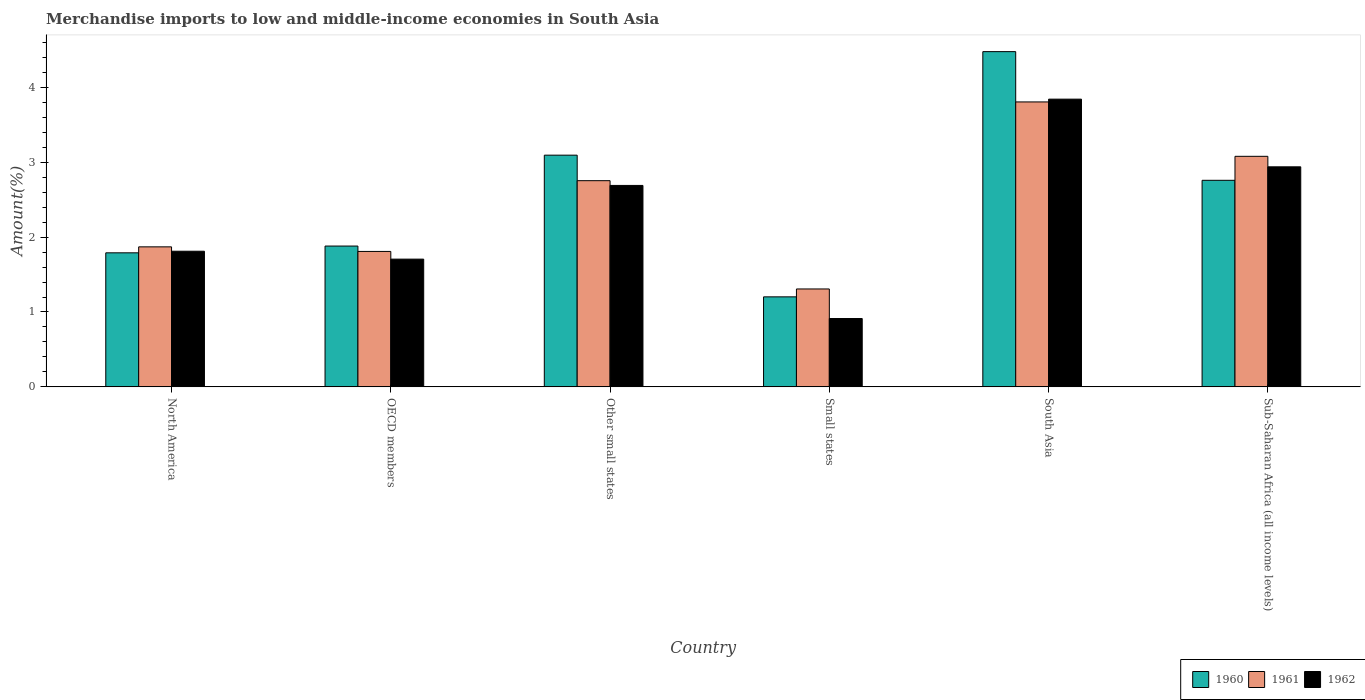How many different coloured bars are there?
Give a very brief answer. 3. How many bars are there on the 5th tick from the left?
Ensure brevity in your answer.  3. How many bars are there on the 6th tick from the right?
Offer a very short reply. 3. What is the label of the 4th group of bars from the left?
Provide a short and direct response. Small states. What is the percentage of amount earned from merchandise imports in 1960 in Other small states?
Your answer should be very brief. 3.09. Across all countries, what is the maximum percentage of amount earned from merchandise imports in 1962?
Offer a terse response. 3.84. Across all countries, what is the minimum percentage of amount earned from merchandise imports in 1960?
Offer a terse response. 1.2. In which country was the percentage of amount earned from merchandise imports in 1960 maximum?
Your answer should be compact. South Asia. In which country was the percentage of amount earned from merchandise imports in 1960 minimum?
Make the answer very short. Small states. What is the total percentage of amount earned from merchandise imports in 1962 in the graph?
Your answer should be compact. 13.9. What is the difference between the percentage of amount earned from merchandise imports in 1960 in Other small states and that in Small states?
Your answer should be very brief. 1.89. What is the difference between the percentage of amount earned from merchandise imports in 1962 in North America and the percentage of amount earned from merchandise imports in 1960 in Small states?
Make the answer very short. 0.61. What is the average percentage of amount earned from merchandise imports in 1961 per country?
Offer a terse response. 2.44. What is the difference between the percentage of amount earned from merchandise imports of/in 1960 and percentage of amount earned from merchandise imports of/in 1961 in Other small states?
Keep it short and to the point. 0.34. In how many countries, is the percentage of amount earned from merchandise imports in 1962 greater than 1.2 %?
Give a very brief answer. 5. What is the ratio of the percentage of amount earned from merchandise imports in 1960 in North America to that in Small states?
Ensure brevity in your answer.  1.49. Is the difference between the percentage of amount earned from merchandise imports in 1960 in North America and South Asia greater than the difference between the percentage of amount earned from merchandise imports in 1961 in North America and South Asia?
Offer a terse response. No. What is the difference between the highest and the second highest percentage of amount earned from merchandise imports in 1960?
Your answer should be compact. -0.34. What is the difference between the highest and the lowest percentage of amount earned from merchandise imports in 1961?
Your response must be concise. 2.5. What does the 1st bar from the left in Small states represents?
Offer a very short reply. 1960. Is it the case that in every country, the sum of the percentage of amount earned from merchandise imports in 1961 and percentage of amount earned from merchandise imports in 1962 is greater than the percentage of amount earned from merchandise imports in 1960?
Your response must be concise. Yes. How many bars are there?
Keep it short and to the point. 18. How many countries are there in the graph?
Your answer should be compact. 6. What is the difference between two consecutive major ticks on the Y-axis?
Offer a terse response. 1. Are the values on the major ticks of Y-axis written in scientific E-notation?
Offer a terse response. No. Where does the legend appear in the graph?
Ensure brevity in your answer.  Bottom right. How many legend labels are there?
Give a very brief answer. 3. What is the title of the graph?
Offer a very short reply. Merchandise imports to low and middle-income economies in South Asia. What is the label or title of the X-axis?
Offer a terse response. Country. What is the label or title of the Y-axis?
Your answer should be very brief. Amount(%). What is the Amount(%) in 1960 in North America?
Ensure brevity in your answer.  1.79. What is the Amount(%) in 1961 in North America?
Make the answer very short. 1.87. What is the Amount(%) of 1962 in North America?
Your answer should be compact. 1.81. What is the Amount(%) of 1960 in OECD members?
Provide a succinct answer. 1.88. What is the Amount(%) in 1961 in OECD members?
Offer a very short reply. 1.81. What is the Amount(%) in 1962 in OECD members?
Provide a short and direct response. 1.71. What is the Amount(%) of 1960 in Other small states?
Provide a short and direct response. 3.09. What is the Amount(%) of 1961 in Other small states?
Your answer should be very brief. 2.75. What is the Amount(%) of 1962 in Other small states?
Your response must be concise. 2.69. What is the Amount(%) in 1960 in Small states?
Make the answer very short. 1.2. What is the Amount(%) in 1961 in Small states?
Provide a short and direct response. 1.31. What is the Amount(%) of 1962 in Small states?
Your answer should be compact. 0.91. What is the Amount(%) of 1960 in South Asia?
Provide a succinct answer. 4.48. What is the Amount(%) in 1961 in South Asia?
Give a very brief answer. 3.8. What is the Amount(%) in 1962 in South Asia?
Offer a terse response. 3.84. What is the Amount(%) of 1960 in Sub-Saharan Africa (all income levels)?
Provide a short and direct response. 2.76. What is the Amount(%) in 1961 in Sub-Saharan Africa (all income levels)?
Your response must be concise. 3.08. What is the Amount(%) of 1962 in Sub-Saharan Africa (all income levels)?
Ensure brevity in your answer.  2.94. Across all countries, what is the maximum Amount(%) of 1960?
Your answer should be very brief. 4.48. Across all countries, what is the maximum Amount(%) of 1961?
Offer a very short reply. 3.8. Across all countries, what is the maximum Amount(%) in 1962?
Give a very brief answer. 3.84. Across all countries, what is the minimum Amount(%) in 1960?
Provide a short and direct response. 1.2. Across all countries, what is the minimum Amount(%) of 1961?
Make the answer very short. 1.31. Across all countries, what is the minimum Amount(%) in 1962?
Keep it short and to the point. 0.91. What is the total Amount(%) in 1960 in the graph?
Provide a succinct answer. 15.2. What is the total Amount(%) in 1961 in the graph?
Your answer should be compact. 14.62. What is the total Amount(%) of 1962 in the graph?
Keep it short and to the point. 13.9. What is the difference between the Amount(%) in 1960 in North America and that in OECD members?
Keep it short and to the point. -0.09. What is the difference between the Amount(%) in 1961 in North America and that in OECD members?
Offer a very short reply. 0.06. What is the difference between the Amount(%) in 1962 in North America and that in OECD members?
Your response must be concise. 0.11. What is the difference between the Amount(%) of 1960 in North America and that in Other small states?
Keep it short and to the point. -1.3. What is the difference between the Amount(%) of 1961 in North America and that in Other small states?
Your answer should be very brief. -0.88. What is the difference between the Amount(%) in 1962 in North America and that in Other small states?
Keep it short and to the point. -0.88. What is the difference between the Amount(%) in 1960 in North America and that in Small states?
Your answer should be compact. 0.59. What is the difference between the Amount(%) in 1961 in North America and that in Small states?
Keep it short and to the point. 0.56. What is the difference between the Amount(%) in 1962 in North America and that in Small states?
Your response must be concise. 0.9. What is the difference between the Amount(%) of 1960 in North America and that in South Asia?
Offer a terse response. -2.69. What is the difference between the Amount(%) of 1961 in North America and that in South Asia?
Ensure brevity in your answer.  -1.94. What is the difference between the Amount(%) of 1962 in North America and that in South Asia?
Keep it short and to the point. -2.03. What is the difference between the Amount(%) in 1960 in North America and that in Sub-Saharan Africa (all income levels)?
Your response must be concise. -0.97. What is the difference between the Amount(%) in 1961 in North America and that in Sub-Saharan Africa (all income levels)?
Offer a terse response. -1.21. What is the difference between the Amount(%) of 1962 in North America and that in Sub-Saharan Africa (all income levels)?
Offer a terse response. -1.13. What is the difference between the Amount(%) of 1960 in OECD members and that in Other small states?
Ensure brevity in your answer.  -1.21. What is the difference between the Amount(%) of 1961 in OECD members and that in Other small states?
Your response must be concise. -0.94. What is the difference between the Amount(%) of 1962 in OECD members and that in Other small states?
Provide a succinct answer. -0.98. What is the difference between the Amount(%) of 1960 in OECD members and that in Small states?
Provide a succinct answer. 0.68. What is the difference between the Amount(%) of 1961 in OECD members and that in Small states?
Your response must be concise. 0.5. What is the difference between the Amount(%) of 1962 in OECD members and that in Small states?
Provide a short and direct response. 0.79. What is the difference between the Amount(%) in 1960 in OECD members and that in South Asia?
Provide a short and direct response. -2.6. What is the difference between the Amount(%) in 1961 in OECD members and that in South Asia?
Ensure brevity in your answer.  -2. What is the difference between the Amount(%) of 1962 in OECD members and that in South Asia?
Your response must be concise. -2.14. What is the difference between the Amount(%) in 1960 in OECD members and that in Sub-Saharan Africa (all income levels)?
Keep it short and to the point. -0.88. What is the difference between the Amount(%) of 1961 in OECD members and that in Sub-Saharan Africa (all income levels)?
Your answer should be very brief. -1.27. What is the difference between the Amount(%) of 1962 in OECD members and that in Sub-Saharan Africa (all income levels)?
Offer a terse response. -1.23. What is the difference between the Amount(%) in 1960 in Other small states and that in Small states?
Keep it short and to the point. 1.89. What is the difference between the Amount(%) of 1961 in Other small states and that in Small states?
Ensure brevity in your answer.  1.45. What is the difference between the Amount(%) of 1962 in Other small states and that in Small states?
Make the answer very short. 1.78. What is the difference between the Amount(%) in 1960 in Other small states and that in South Asia?
Give a very brief answer. -1.38. What is the difference between the Amount(%) of 1961 in Other small states and that in South Asia?
Offer a very short reply. -1.05. What is the difference between the Amount(%) of 1962 in Other small states and that in South Asia?
Give a very brief answer. -1.15. What is the difference between the Amount(%) of 1960 in Other small states and that in Sub-Saharan Africa (all income levels)?
Provide a short and direct response. 0.34. What is the difference between the Amount(%) of 1961 in Other small states and that in Sub-Saharan Africa (all income levels)?
Your answer should be compact. -0.33. What is the difference between the Amount(%) in 1962 in Other small states and that in Sub-Saharan Africa (all income levels)?
Give a very brief answer. -0.25. What is the difference between the Amount(%) in 1960 in Small states and that in South Asia?
Your answer should be compact. -3.27. What is the difference between the Amount(%) of 1961 in Small states and that in South Asia?
Offer a terse response. -2.5. What is the difference between the Amount(%) of 1962 in Small states and that in South Asia?
Your response must be concise. -2.93. What is the difference between the Amount(%) in 1960 in Small states and that in Sub-Saharan Africa (all income levels)?
Offer a very short reply. -1.56. What is the difference between the Amount(%) of 1961 in Small states and that in Sub-Saharan Africa (all income levels)?
Offer a terse response. -1.77. What is the difference between the Amount(%) in 1962 in Small states and that in Sub-Saharan Africa (all income levels)?
Your answer should be very brief. -2.03. What is the difference between the Amount(%) in 1960 in South Asia and that in Sub-Saharan Africa (all income levels)?
Your answer should be very brief. 1.72. What is the difference between the Amount(%) of 1961 in South Asia and that in Sub-Saharan Africa (all income levels)?
Your response must be concise. 0.73. What is the difference between the Amount(%) of 1962 in South Asia and that in Sub-Saharan Africa (all income levels)?
Provide a succinct answer. 0.9. What is the difference between the Amount(%) in 1960 in North America and the Amount(%) in 1961 in OECD members?
Offer a terse response. -0.02. What is the difference between the Amount(%) of 1960 in North America and the Amount(%) of 1962 in OECD members?
Your response must be concise. 0.08. What is the difference between the Amount(%) of 1961 in North America and the Amount(%) of 1962 in OECD members?
Provide a short and direct response. 0.16. What is the difference between the Amount(%) of 1960 in North America and the Amount(%) of 1961 in Other small states?
Offer a very short reply. -0.96. What is the difference between the Amount(%) of 1960 in North America and the Amount(%) of 1962 in Other small states?
Ensure brevity in your answer.  -0.9. What is the difference between the Amount(%) of 1961 in North America and the Amount(%) of 1962 in Other small states?
Offer a very short reply. -0.82. What is the difference between the Amount(%) in 1960 in North America and the Amount(%) in 1961 in Small states?
Your response must be concise. 0.48. What is the difference between the Amount(%) of 1960 in North America and the Amount(%) of 1962 in Small states?
Ensure brevity in your answer.  0.88. What is the difference between the Amount(%) in 1961 in North America and the Amount(%) in 1962 in Small states?
Your answer should be compact. 0.96. What is the difference between the Amount(%) in 1960 in North America and the Amount(%) in 1961 in South Asia?
Make the answer very short. -2.01. What is the difference between the Amount(%) in 1960 in North America and the Amount(%) in 1962 in South Asia?
Provide a short and direct response. -2.05. What is the difference between the Amount(%) of 1961 in North America and the Amount(%) of 1962 in South Asia?
Offer a very short reply. -1.97. What is the difference between the Amount(%) in 1960 in North America and the Amount(%) in 1961 in Sub-Saharan Africa (all income levels)?
Provide a short and direct response. -1.29. What is the difference between the Amount(%) in 1960 in North America and the Amount(%) in 1962 in Sub-Saharan Africa (all income levels)?
Offer a very short reply. -1.15. What is the difference between the Amount(%) in 1961 in North America and the Amount(%) in 1962 in Sub-Saharan Africa (all income levels)?
Keep it short and to the point. -1.07. What is the difference between the Amount(%) in 1960 in OECD members and the Amount(%) in 1961 in Other small states?
Your answer should be compact. -0.87. What is the difference between the Amount(%) of 1960 in OECD members and the Amount(%) of 1962 in Other small states?
Keep it short and to the point. -0.81. What is the difference between the Amount(%) of 1961 in OECD members and the Amount(%) of 1962 in Other small states?
Your response must be concise. -0.88. What is the difference between the Amount(%) in 1960 in OECD members and the Amount(%) in 1961 in Small states?
Provide a short and direct response. 0.57. What is the difference between the Amount(%) of 1960 in OECD members and the Amount(%) of 1962 in Small states?
Your answer should be compact. 0.97. What is the difference between the Amount(%) of 1961 in OECD members and the Amount(%) of 1962 in Small states?
Ensure brevity in your answer.  0.9. What is the difference between the Amount(%) of 1960 in OECD members and the Amount(%) of 1961 in South Asia?
Ensure brevity in your answer.  -1.92. What is the difference between the Amount(%) of 1960 in OECD members and the Amount(%) of 1962 in South Asia?
Provide a succinct answer. -1.96. What is the difference between the Amount(%) of 1961 in OECD members and the Amount(%) of 1962 in South Asia?
Your answer should be very brief. -2.03. What is the difference between the Amount(%) of 1960 in OECD members and the Amount(%) of 1961 in Sub-Saharan Africa (all income levels)?
Make the answer very short. -1.2. What is the difference between the Amount(%) of 1960 in OECD members and the Amount(%) of 1962 in Sub-Saharan Africa (all income levels)?
Your answer should be very brief. -1.06. What is the difference between the Amount(%) of 1961 in OECD members and the Amount(%) of 1962 in Sub-Saharan Africa (all income levels)?
Ensure brevity in your answer.  -1.13. What is the difference between the Amount(%) in 1960 in Other small states and the Amount(%) in 1961 in Small states?
Offer a terse response. 1.79. What is the difference between the Amount(%) of 1960 in Other small states and the Amount(%) of 1962 in Small states?
Provide a short and direct response. 2.18. What is the difference between the Amount(%) of 1961 in Other small states and the Amount(%) of 1962 in Small states?
Your answer should be very brief. 1.84. What is the difference between the Amount(%) of 1960 in Other small states and the Amount(%) of 1961 in South Asia?
Keep it short and to the point. -0.71. What is the difference between the Amount(%) of 1960 in Other small states and the Amount(%) of 1962 in South Asia?
Offer a terse response. -0.75. What is the difference between the Amount(%) in 1961 in Other small states and the Amount(%) in 1962 in South Asia?
Ensure brevity in your answer.  -1.09. What is the difference between the Amount(%) of 1960 in Other small states and the Amount(%) of 1961 in Sub-Saharan Africa (all income levels)?
Your answer should be compact. 0.02. What is the difference between the Amount(%) in 1960 in Other small states and the Amount(%) in 1962 in Sub-Saharan Africa (all income levels)?
Keep it short and to the point. 0.16. What is the difference between the Amount(%) in 1961 in Other small states and the Amount(%) in 1962 in Sub-Saharan Africa (all income levels)?
Your answer should be very brief. -0.18. What is the difference between the Amount(%) in 1960 in Small states and the Amount(%) in 1961 in South Asia?
Ensure brevity in your answer.  -2.6. What is the difference between the Amount(%) of 1960 in Small states and the Amount(%) of 1962 in South Asia?
Give a very brief answer. -2.64. What is the difference between the Amount(%) of 1961 in Small states and the Amount(%) of 1962 in South Asia?
Provide a short and direct response. -2.53. What is the difference between the Amount(%) of 1960 in Small states and the Amount(%) of 1961 in Sub-Saharan Africa (all income levels)?
Offer a very short reply. -1.88. What is the difference between the Amount(%) of 1960 in Small states and the Amount(%) of 1962 in Sub-Saharan Africa (all income levels)?
Your answer should be compact. -1.74. What is the difference between the Amount(%) in 1961 in Small states and the Amount(%) in 1962 in Sub-Saharan Africa (all income levels)?
Ensure brevity in your answer.  -1.63. What is the difference between the Amount(%) in 1960 in South Asia and the Amount(%) in 1961 in Sub-Saharan Africa (all income levels)?
Your answer should be compact. 1.4. What is the difference between the Amount(%) of 1960 in South Asia and the Amount(%) of 1962 in Sub-Saharan Africa (all income levels)?
Ensure brevity in your answer.  1.54. What is the difference between the Amount(%) in 1961 in South Asia and the Amount(%) in 1962 in Sub-Saharan Africa (all income levels)?
Provide a succinct answer. 0.87. What is the average Amount(%) of 1960 per country?
Your answer should be compact. 2.53. What is the average Amount(%) in 1961 per country?
Provide a succinct answer. 2.44. What is the average Amount(%) of 1962 per country?
Your answer should be compact. 2.32. What is the difference between the Amount(%) of 1960 and Amount(%) of 1961 in North America?
Provide a short and direct response. -0.08. What is the difference between the Amount(%) of 1960 and Amount(%) of 1962 in North America?
Provide a short and direct response. -0.02. What is the difference between the Amount(%) of 1961 and Amount(%) of 1962 in North America?
Give a very brief answer. 0.06. What is the difference between the Amount(%) of 1960 and Amount(%) of 1961 in OECD members?
Your response must be concise. 0.07. What is the difference between the Amount(%) of 1960 and Amount(%) of 1962 in OECD members?
Give a very brief answer. 0.17. What is the difference between the Amount(%) of 1961 and Amount(%) of 1962 in OECD members?
Ensure brevity in your answer.  0.1. What is the difference between the Amount(%) in 1960 and Amount(%) in 1961 in Other small states?
Your answer should be very brief. 0.34. What is the difference between the Amount(%) in 1960 and Amount(%) in 1962 in Other small states?
Your answer should be very brief. 0.4. What is the difference between the Amount(%) in 1961 and Amount(%) in 1962 in Other small states?
Ensure brevity in your answer.  0.06. What is the difference between the Amount(%) in 1960 and Amount(%) in 1961 in Small states?
Offer a terse response. -0.11. What is the difference between the Amount(%) of 1960 and Amount(%) of 1962 in Small states?
Your answer should be compact. 0.29. What is the difference between the Amount(%) in 1961 and Amount(%) in 1962 in Small states?
Provide a short and direct response. 0.39. What is the difference between the Amount(%) of 1960 and Amount(%) of 1961 in South Asia?
Make the answer very short. 0.67. What is the difference between the Amount(%) in 1960 and Amount(%) in 1962 in South Asia?
Make the answer very short. 0.63. What is the difference between the Amount(%) in 1961 and Amount(%) in 1962 in South Asia?
Keep it short and to the point. -0.04. What is the difference between the Amount(%) in 1960 and Amount(%) in 1961 in Sub-Saharan Africa (all income levels)?
Your answer should be compact. -0.32. What is the difference between the Amount(%) in 1960 and Amount(%) in 1962 in Sub-Saharan Africa (all income levels)?
Keep it short and to the point. -0.18. What is the difference between the Amount(%) in 1961 and Amount(%) in 1962 in Sub-Saharan Africa (all income levels)?
Offer a terse response. 0.14. What is the ratio of the Amount(%) of 1960 in North America to that in OECD members?
Your answer should be compact. 0.95. What is the ratio of the Amount(%) of 1961 in North America to that in OECD members?
Your answer should be very brief. 1.03. What is the ratio of the Amount(%) in 1962 in North America to that in OECD members?
Your answer should be very brief. 1.06. What is the ratio of the Amount(%) of 1960 in North America to that in Other small states?
Ensure brevity in your answer.  0.58. What is the ratio of the Amount(%) of 1961 in North America to that in Other small states?
Your response must be concise. 0.68. What is the ratio of the Amount(%) of 1962 in North America to that in Other small states?
Offer a terse response. 0.67. What is the ratio of the Amount(%) of 1960 in North America to that in Small states?
Make the answer very short. 1.49. What is the ratio of the Amount(%) of 1961 in North America to that in Small states?
Your response must be concise. 1.43. What is the ratio of the Amount(%) of 1962 in North America to that in Small states?
Give a very brief answer. 1.98. What is the ratio of the Amount(%) in 1960 in North America to that in South Asia?
Offer a terse response. 0.4. What is the ratio of the Amount(%) of 1961 in North America to that in South Asia?
Offer a very short reply. 0.49. What is the ratio of the Amount(%) in 1962 in North America to that in South Asia?
Keep it short and to the point. 0.47. What is the ratio of the Amount(%) of 1960 in North America to that in Sub-Saharan Africa (all income levels)?
Offer a very short reply. 0.65. What is the ratio of the Amount(%) in 1961 in North America to that in Sub-Saharan Africa (all income levels)?
Your answer should be very brief. 0.61. What is the ratio of the Amount(%) of 1962 in North America to that in Sub-Saharan Africa (all income levels)?
Keep it short and to the point. 0.62. What is the ratio of the Amount(%) of 1960 in OECD members to that in Other small states?
Your answer should be very brief. 0.61. What is the ratio of the Amount(%) of 1961 in OECD members to that in Other small states?
Provide a short and direct response. 0.66. What is the ratio of the Amount(%) in 1962 in OECD members to that in Other small states?
Offer a terse response. 0.63. What is the ratio of the Amount(%) in 1960 in OECD members to that in Small states?
Provide a succinct answer. 1.56. What is the ratio of the Amount(%) in 1961 in OECD members to that in Small states?
Your answer should be very brief. 1.38. What is the ratio of the Amount(%) in 1962 in OECD members to that in Small states?
Your answer should be very brief. 1.87. What is the ratio of the Amount(%) of 1960 in OECD members to that in South Asia?
Offer a very short reply. 0.42. What is the ratio of the Amount(%) of 1961 in OECD members to that in South Asia?
Ensure brevity in your answer.  0.48. What is the ratio of the Amount(%) in 1962 in OECD members to that in South Asia?
Make the answer very short. 0.44. What is the ratio of the Amount(%) of 1960 in OECD members to that in Sub-Saharan Africa (all income levels)?
Give a very brief answer. 0.68. What is the ratio of the Amount(%) of 1961 in OECD members to that in Sub-Saharan Africa (all income levels)?
Provide a short and direct response. 0.59. What is the ratio of the Amount(%) of 1962 in OECD members to that in Sub-Saharan Africa (all income levels)?
Provide a short and direct response. 0.58. What is the ratio of the Amount(%) in 1960 in Other small states to that in Small states?
Offer a very short reply. 2.57. What is the ratio of the Amount(%) of 1961 in Other small states to that in Small states?
Make the answer very short. 2.11. What is the ratio of the Amount(%) of 1962 in Other small states to that in Small states?
Offer a terse response. 2.95. What is the ratio of the Amount(%) in 1960 in Other small states to that in South Asia?
Offer a terse response. 0.69. What is the ratio of the Amount(%) in 1961 in Other small states to that in South Asia?
Provide a succinct answer. 0.72. What is the ratio of the Amount(%) of 1962 in Other small states to that in South Asia?
Your answer should be compact. 0.7. What is the ratio of the Amount(%) in 1960 in Other small states to that in Sub-Saharan Africa (all income levels)?
Provide a short and direct response. 1.12. What is the ratio of the Amount(%) of 1961 in Other small states to that in Sub-Saharan Africa (all income levels)?
Your response must be concise. 0.89. What is the ratio of the Amount(%) of 1962 in Other small states to that in Sub-Saharan Africa (all income levels)?
Give a very brief answer. 0.92. What is the ratio of the Amount(%) of 1960 in Small states to that in South Asia?
Ensure brevity in your answer.  0.27. What is the ratio of the Amount(%) in 1961 in Small states to that in South Asia?
Ensure brevity in your answer.  0.34. What is the ratio of the Amount(%) in 1962 in Small states to that in South Asia?
Your answer should be very brief. 0.24. What is the ratio of the Amount(%) in 1960 in Small states to that in Sub-Saharan Africa (all income levels)?
Your answer should be compact. 0.44. What is the ratio of the Amount(%) of 1961 in Small states to that in Sub-Saharan Africa (all income levels)?
Your answer should be compact. 0.42. What is the ratio of the Amount(%) in 1962 in Small states to that in Sub-Saharan Africa (all income levels)?
Make the answer very short. 0.31. What is the ratio of the Amount(%) of 1960 in South Asia to that in Sub-Saharan Africa (all income levels)?
Ensure brevity in your answer.  1.62. What is the ratio of the Amount(%) in 1961 in South Asia to that in Sub-Saharan Africa (all income levels)?
Provide a short and direct response. 1.24. What is the ratio of the Amount(%) in 1962 in South Asia to that in Sub-Saharan Africa (all income levels)?
Give a very brief answer. 1.31. What is the difference between the highest and the second highest Amount(%) in 1960?
Provide a short and direct response. 1.38. What is the difference between the highest and the second highest Amount(%) of 1961?
Provide a succinct answer. 0.73. What is the difference between the highest and the second highest Amount(%) of 1962?
Provide a succinct answer. 0.9. What is the difference between the highest and the lowest Amount(%) in 1960?
Your response must be concise. 3.27. What is the difference between the highest and the lowest Amount(%) of 1961?
Offer a very short reply. 2.5. What is the difference between the highest and the lowest Amount(%) in 1962?
Keep it short and to the point. 2.93. 